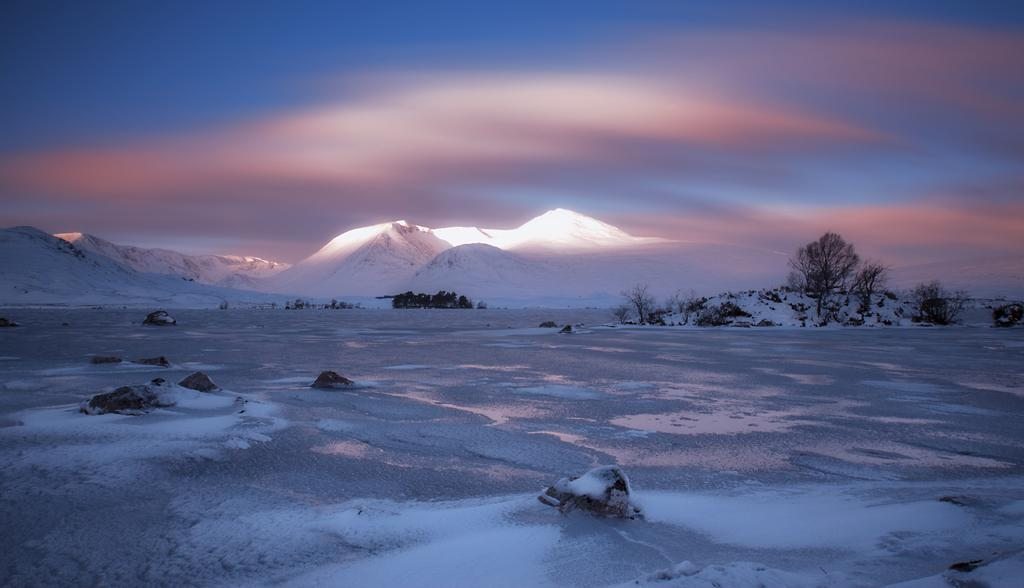What type of geographical feature can be seen in the image? There are mountains in the image. What type of vegetation is present in the image? There are trees in the image. What is the condition of the land in the image? The land is covered with snow. How would you describe the sky in the image? The sky is partially gloomy. What type of authority figure can be seen in the image? There is no authority figure present in the image. Is the image depicting a hot environment? The image does not indicate a hot environment, as the land is covered with snow. 